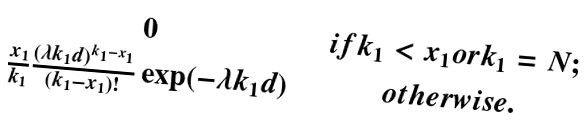Convert formula to latex. <formula><loc_0><loc_0><loc_500><loc_500>\begin{matrix} 0 & & \, i f k _ { 1 } < x _ { 1 } o r k _ { 1 } = N ; \\ \frac { x _ { 1 } } { k _ { 1 } } \frac { ( \lambda k _ { 1 } d ) ^ { k _ { 1 } { - } x _ { 1 } } } { ( k _ { 1 } { - } x _ { 1 } ) ! } \exp ( - \lambda k _ { 1 } d ) & & o t h e r w i s e . \end{matrix}</formula> 